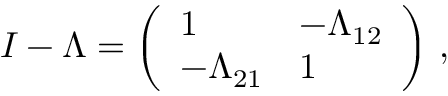Convert formula to latex. <formula><loc_0><loc_0><loc_500><loc_500>I - \Lambda = \left ( \begin{array} { l l } { 1 } & { - \Lambda _ { 1 2 } } \\ { - \Lambda _ { 2 1 } } & { 1 } \end{array} \right ) \, ,</formula> 